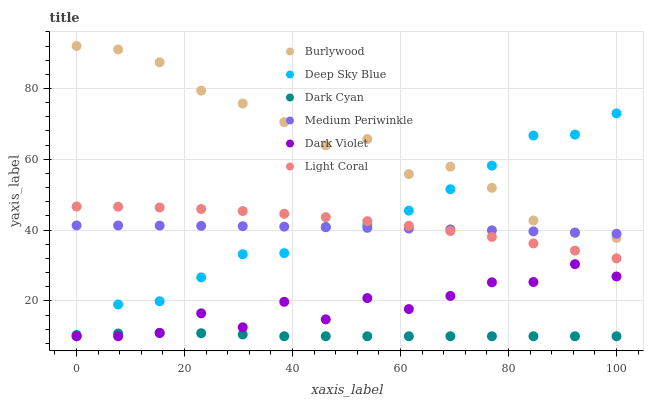Does Dark Cyan have the minimum area under the curve?
Answer yes or no. Yes. Does Burlywood have the maximum area under the curve?
Answer yes or no. Yes. Does Medium Periwinkle have the minimum area under the curve?
Answer yes or no. No. Does Medium Periwinkle have the maximum area under the curve?
Answer yes or no. No. Is Medium Periwinkle the smoothest?
Answer yes or no. Yes. Is Dark Violet the roughest?
Answer yes or no. Yes. Is Dark Violet the smoothest?
Answer yes or no. No. Is Medium Periwinkle the roughest?
Answer yes or no. No. Does Dark Violet have the lowest value?
Answer yes or no. Yes. Does Medium Periwinkle have the lowest value?
Answer yes or no. No. Does Burlywood have the highest value?
Answer yes or no. Yes. Does Medium Periwinkle have the highest value?
Answer yes or no. No. Is Dark Cyan less than Burlywood?
Answer yes or no. Yes. Is Light Coral greater than Dark Cyan?
Answer yes or no. Yes. Does Medium Periwinkle intersect Burlywood?
Answer yes or no. Yes. Is Medium Periwinkle less than Burlywood?
Answer yes or no. No. Is Medium Periwinkle greater than Burlywood?
Answer yes or no. No. Does Dark Cyan intersect Burlywood?
Answer yes or no. No. 